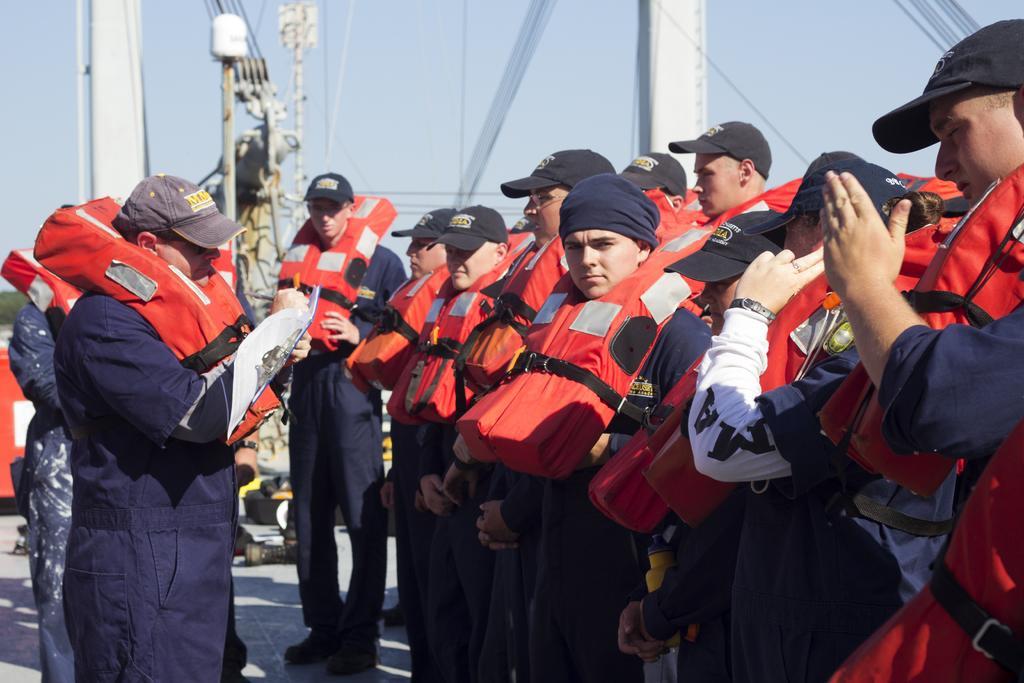Describe this image in one or two sentences. In this image I can see number of people are standing and I can see all of them are wearing blue colour dress, caps and orange colour life jackets. In the background I can see few poles, wires, shadows and here I can see he is holding a paper. 